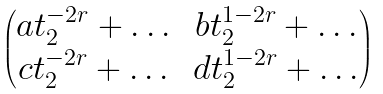<formula> <loc_0><loc_0><loc_500><loc_500>\begin{pmatrix} a t _ { 2 } ^ { - 2 r } + \dots & b t _ { 2 } ^ { 1 - 2 r } + \dots \\ c t _ { 2 } ^ { - 2 r } + \dots & d t _ { 2 } ^ { 1 - 2 r } + \dots \end{pmatrix}</formula> 